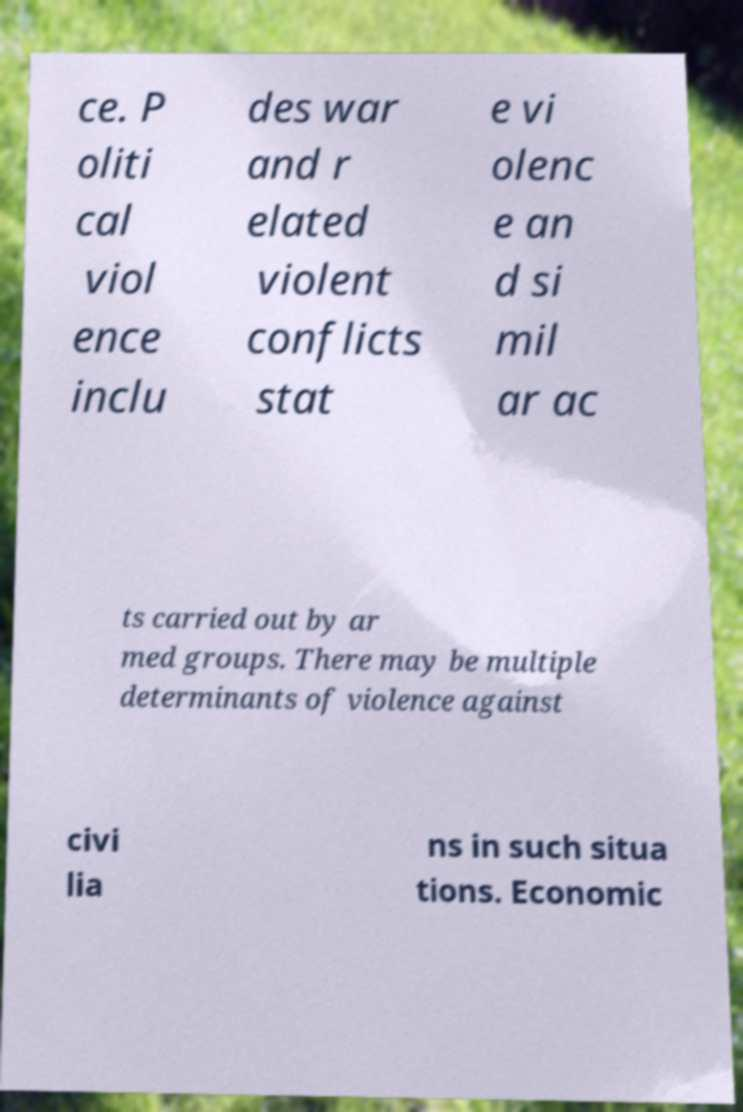There's text embedded in this image that I need extracted. Can you transcribe it verbatim? ce. P oliti cal viol ence inclu des war and r elated violent conflicts stat e vi olenc e an d si mil ar ac ts carried out by ar med groups. There may be multiple determinants of violence against civi lia ns in such situa tions. Economic 